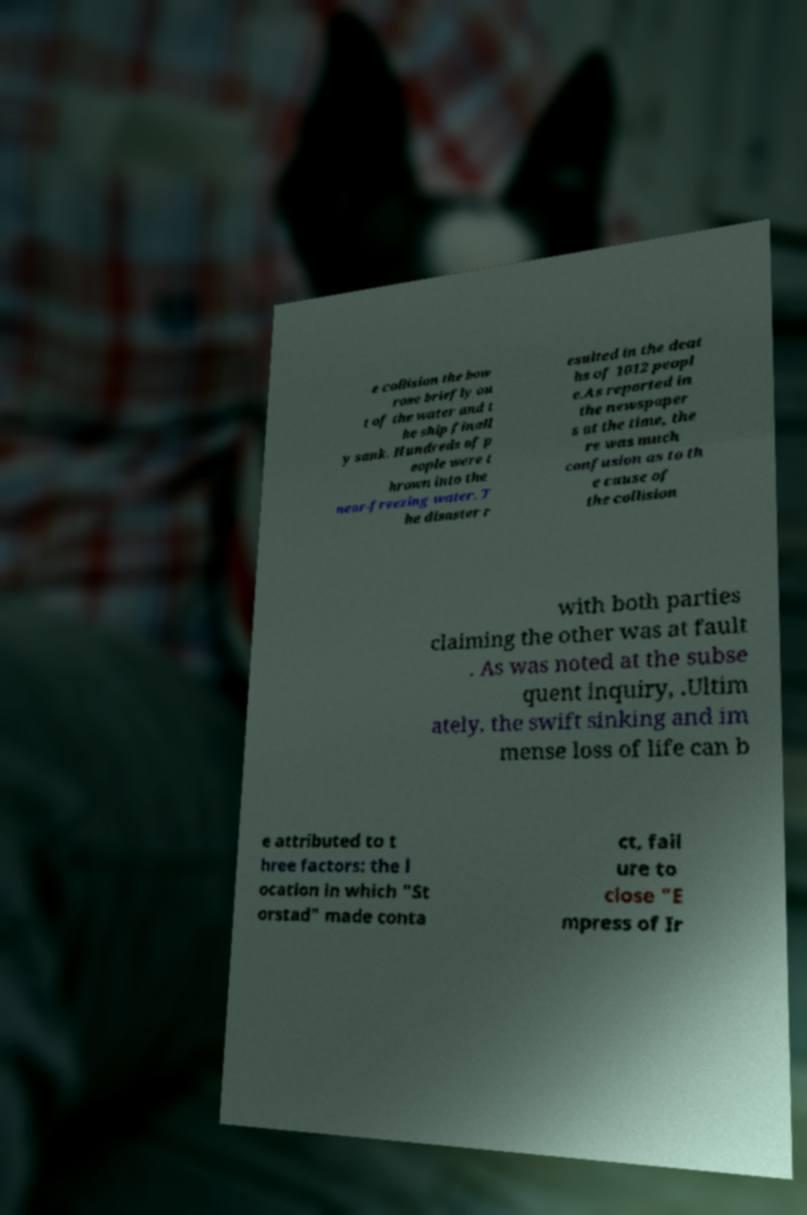Please identify and transcribe the text found in this image. e collision the bow rose briefly ou t of the water and t he ship finall y sank. Hundreds of p eople were t hrown into the near-freezing water. T he disaster r esulted in the deat hs of 1012 peopl e.As reported in the newspaper s at the time, the re was much confusion as to th e cause of the collision with both parties claiming the other was at fault . As was noted at the subse quent inquiry, .Ultim ately, the swift sinking and im mense loss of life can b e attributed to t hree factors: the l ocation in which "St orstad" made conta ct, fail ure to close "E mpress of Ir 